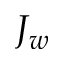<formula> <loc_0><loc_0><loc_500><loc_500>J _ { w }</formula> 